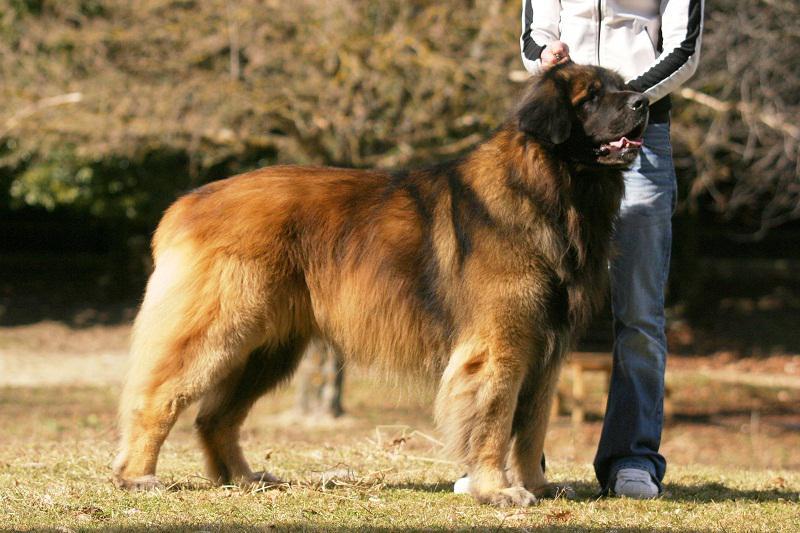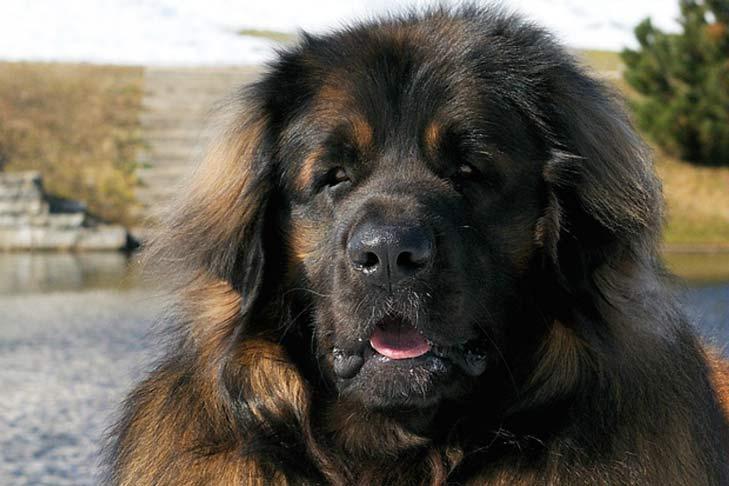The first image is the image on the left, the second image is the image on the right. Considering the images on both sides, is "Some dogs are sitting on the ground." valid? Answer yes or no. No. 